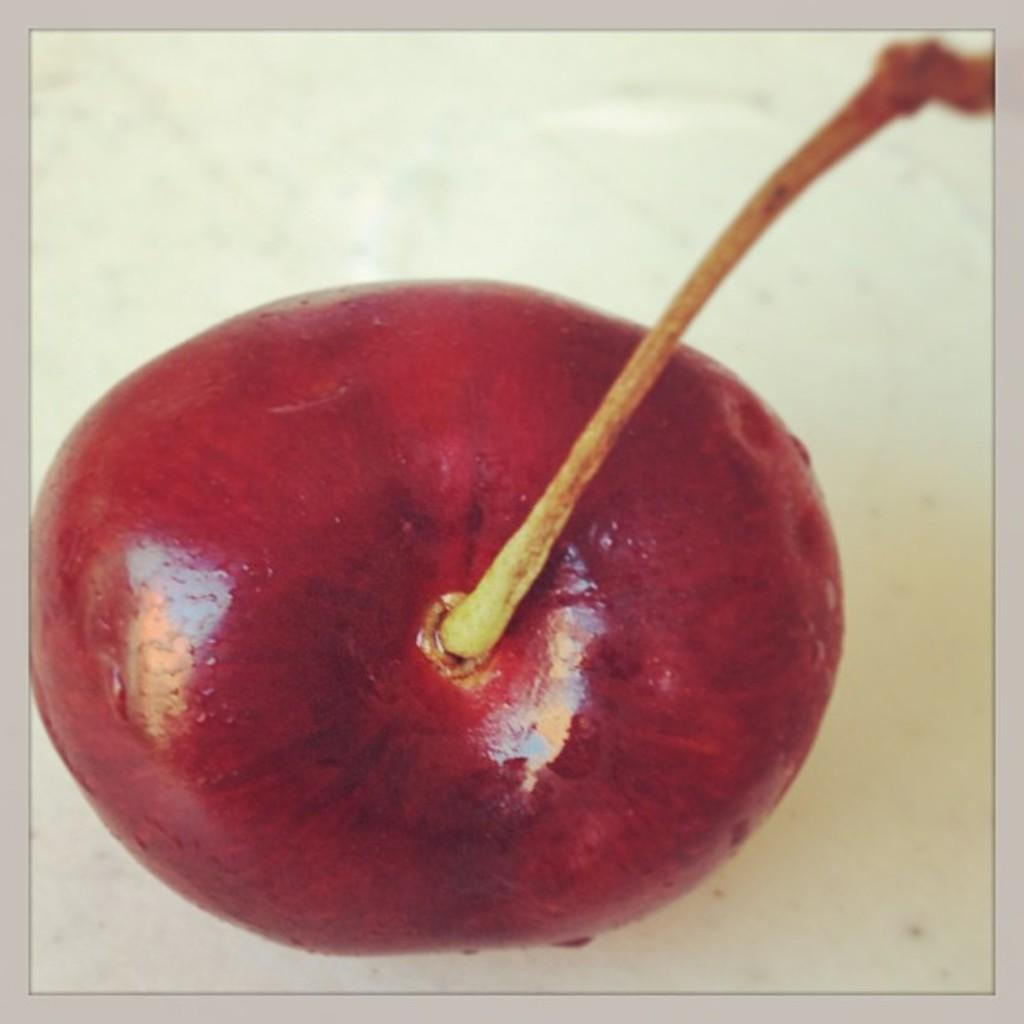What is the main subject of the image? The main subject of the image is an apple. How is the apple being viewed in the image? The apple is viewed from the top. What can be seen at the top of the apple? There is a twig visible at the top of the apple. How many hands are holding the apple in the image? There are no hands visible in the image; the apple is viewed from the top, and a twig is present at the top of the apple. What type of quiver is attached to the apple in the image? There is no quiver present in the image; the main subject is an apple with a twig at the top. 